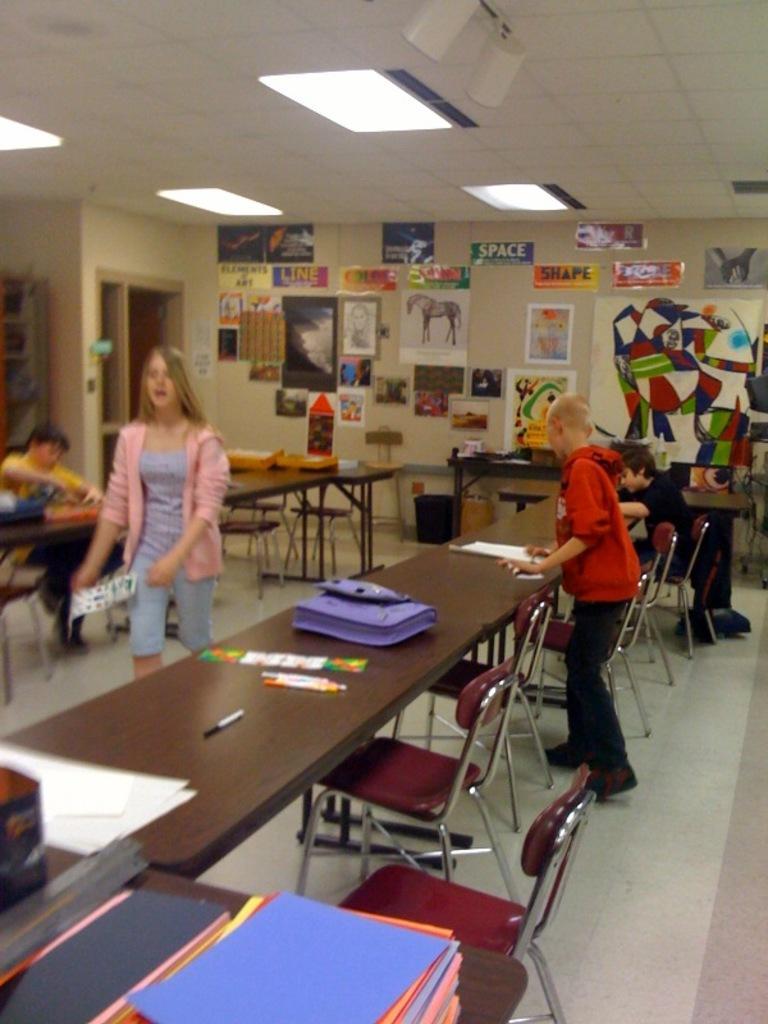In one or two sentences, can you explain what this image depicts? In this image, There is a table which is in black color, There are some chairs which are in red color, There are some people standing, In the background there is a wall which is in white color there are some pictures pasted, In the top there is a white color roof. 